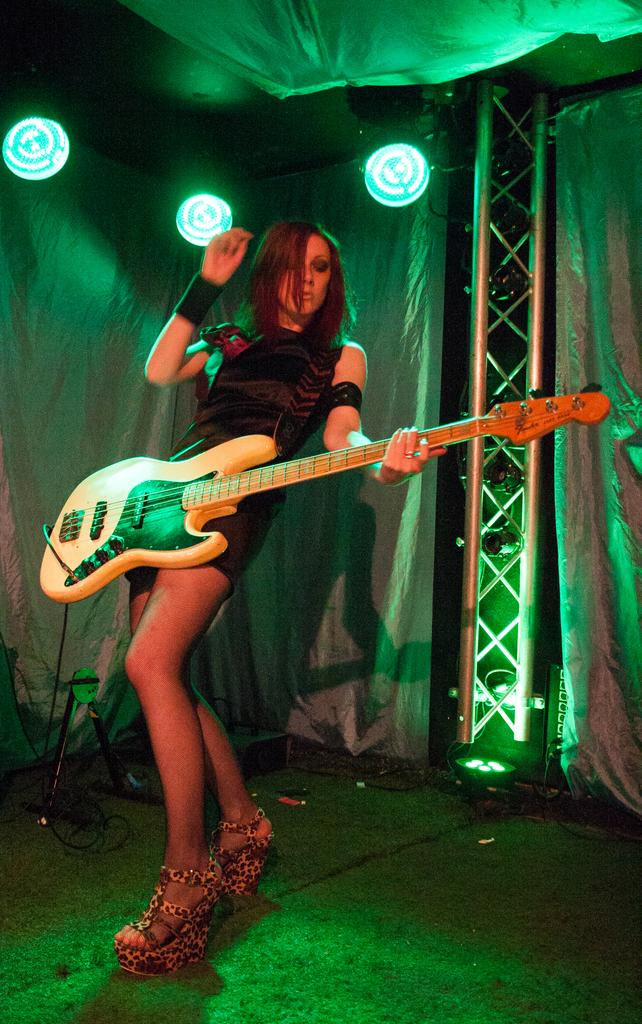Who is the main subject in the image? There is a woman in the image. What is the woman holding in the image? The woman is holding a guitar. What is the woman's posture in the image? The woman is bending. What can be seen in the background of the image? There are curtains, a light, and a pillar in the background of the image. How many men are visible in the image? There are no men visible in the image; it features a woman holding a guitar. Can you tell me what type of monkey is sitting on the pillar in the background? There is no monkey present in the image; only the woman, guitar, and background elements are visible. 